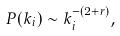<formula> <loc_0><loc_0><loc_500><loc_500>P ( k _ { i } ) \sim k _ { i } ^ { - ( 2 + r ) } ,</formula> 